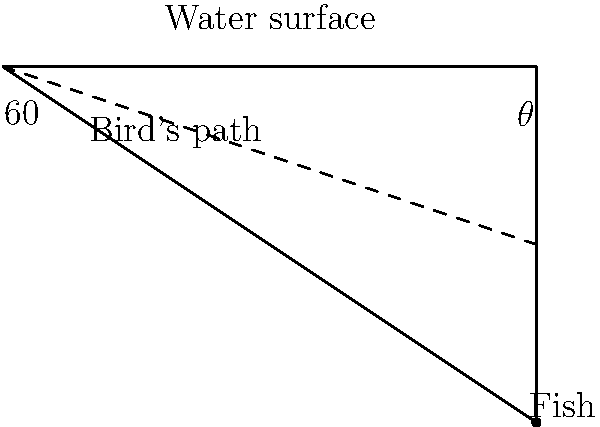A diving bird spots a fish and descends at a 60° angle from the horizontal water surface. If the bird's path forms a right angle with the water surface and the fish's position, what is the angle $\theta$ between the water surface and the line connecting the bird's entry point to the fish? Let's approach this step-by-step:

1) First, we need to recognize that we have a right-angled triangle. The right angle is formed where the bird's path meets the line from the entry point to the fish.

2) We know one angle of this triangle: the bird's descent angle of 60°.

3) In a right-angled triangle, the sum of all angles must be 180°. So if we know two angles, we can find the third.

4) Let's call our unknown angle $\theta$. We can set up an equation:

   $60° + 90° + \theta = 180°$

5) Simplifying:
   $150° + \theta = 180°$

6) Subtracting 150° from both sides:
   $\theta = 180° - 150° = 30°$

Therefore, the angle $\theta$ between the water surface and the line connecting the bird's entry point to the fish is 30°.
Answer: $30°$ 